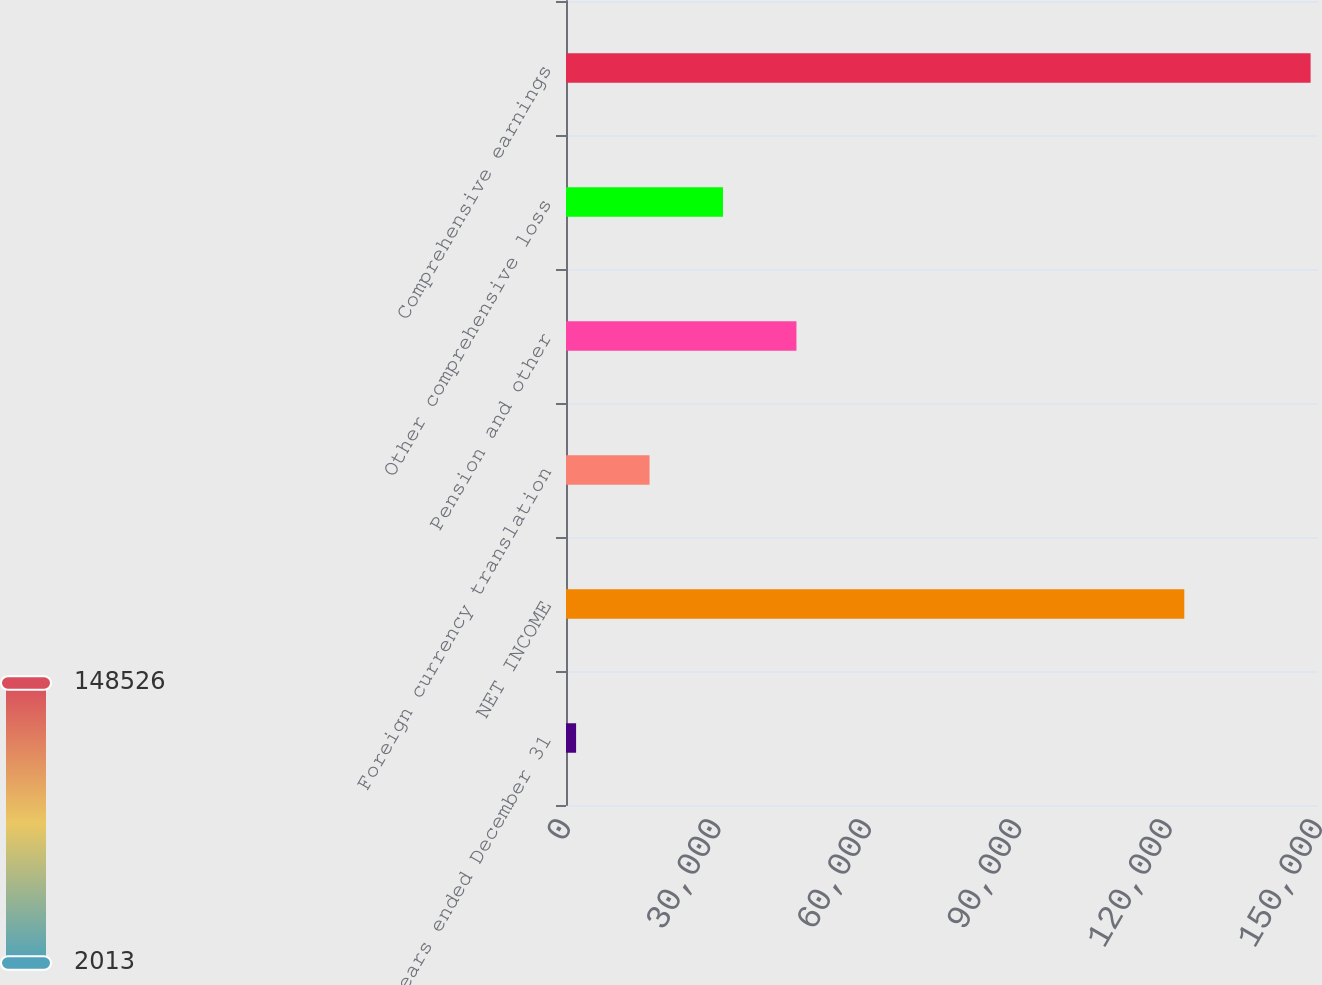<chart> <loc_0><loc_0><loc_500><loc_500><bar_chart><fcel>Years ended December 31<fcel>NET INCOME<fcel>Foreign currency translation<fcel>Pension and other<fcel>Other comprehensive loss<fcel>Comprehensive earnings<nl><fcel>2013<fcel>123330<fcel>16664.3<fcel>45966.9<fcel>31315.6<fcel>148526<nl></chart> 